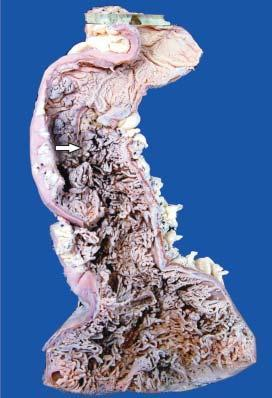what is straddled with multiple polyoid structures of varying sizes many of which are pedunculated?
Answer the question using a single word or phrase. Mucosal surface 